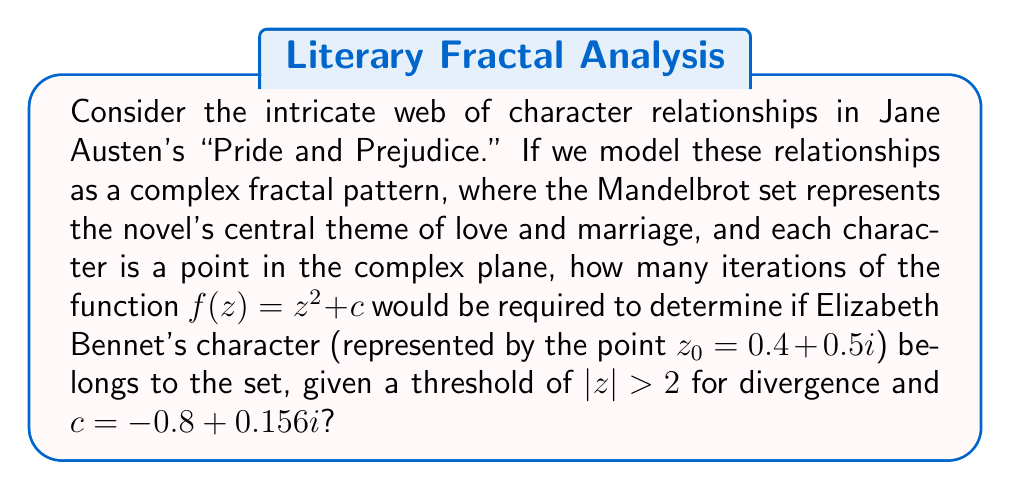Show me your answer to this math problem. To solve this problem, we need to iterate the function $f(z) = z^2 + c$ starting with $z_0 = 0.4 + 0.5i$ and $c = -0.8 + 0.156i$ until either $|z| > 2$ or we reach a predetermined maximum number of iterations.

Let's calculate step by step:

1) $z_0 = 0.4 + 0.5i$

2) $z_1 = z_0^2 + c$
   $= (0.4 + 0.5i)^2 + (-0.8 + 0.156i)$
   $= (0.16 - 0.25 + 0.4i) + (-0.8 + 0.156i)$
   $= -0.89 + 0.556i$

3) $z_2 = z_1^2 + c$
   $= (-0.89 + 0.556i)^2 + (-0.8 + 0.156i)$
   $= (0.7921 - 0.9888i + 0.309136) + (-0.8 + 0.156i)$
   $= 0.301236 - 0.8328i$

4) $z_3 = z_2^2 + c$
   $= (0.301236 - 0.8328i)^2 + (-0.8 + 0.156i)$
   $= (-0.602548 - 0.501872i) + (-0.8 + 0.156i)$
   $= -1.402548 - 0.345872i$

5) $|z_3| = \sqrt{(-1.402548)^2 + (-0.345872)^2} \approx 1.4431$

6) $z_4 = z_3^2 + c$
   $= (-1.402548 - 0.345872i)^2 + (-0.8 + 0.156i)$
   $= (1.469128 + 0.969744i) + (-0.8 + 0.156i)$
   $= 0.669128 + 1.125744i$

7) $|z_4| = \sqrt{(0.669128)^2 + (1.125744)^2} \approx 1.3089$

8) $z_5 = z_4^2 + c$
   $= (0.669128 + 1.125744i)^2 + (-0.8 + 0.156i)$
   $= (-0.576995 + 1.506133i) + (-0.8 + 0.156i)$
   $= -1.376995 + 1.662133i$

9) $|z_5| = \sqrt{(-1.376995)^2 + (1.662133)^2} \approx 2.1588$

Since $|z_5| > 2$, we stop at the 5th iteration.
Answer: 5 iterations 